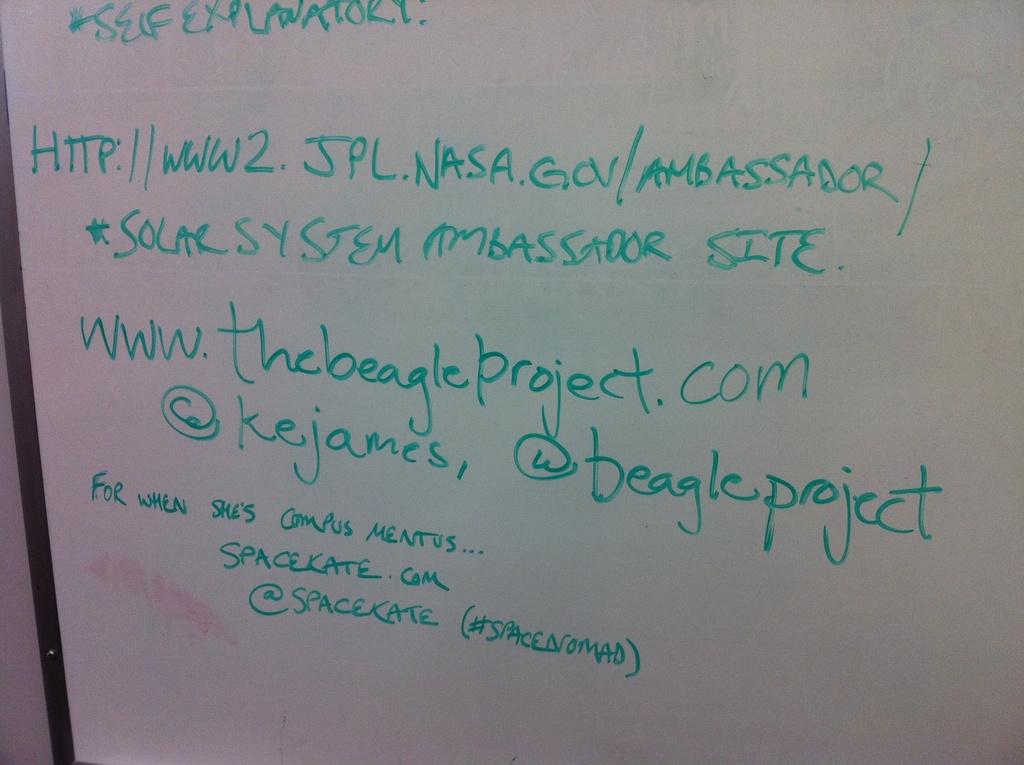What is the twitter handle for the beagle project?
Keep it short and to the point. @beagleproject. What website is advertised second?
Ensure brevity in your answer.  Www.thebeagleproject.com. 